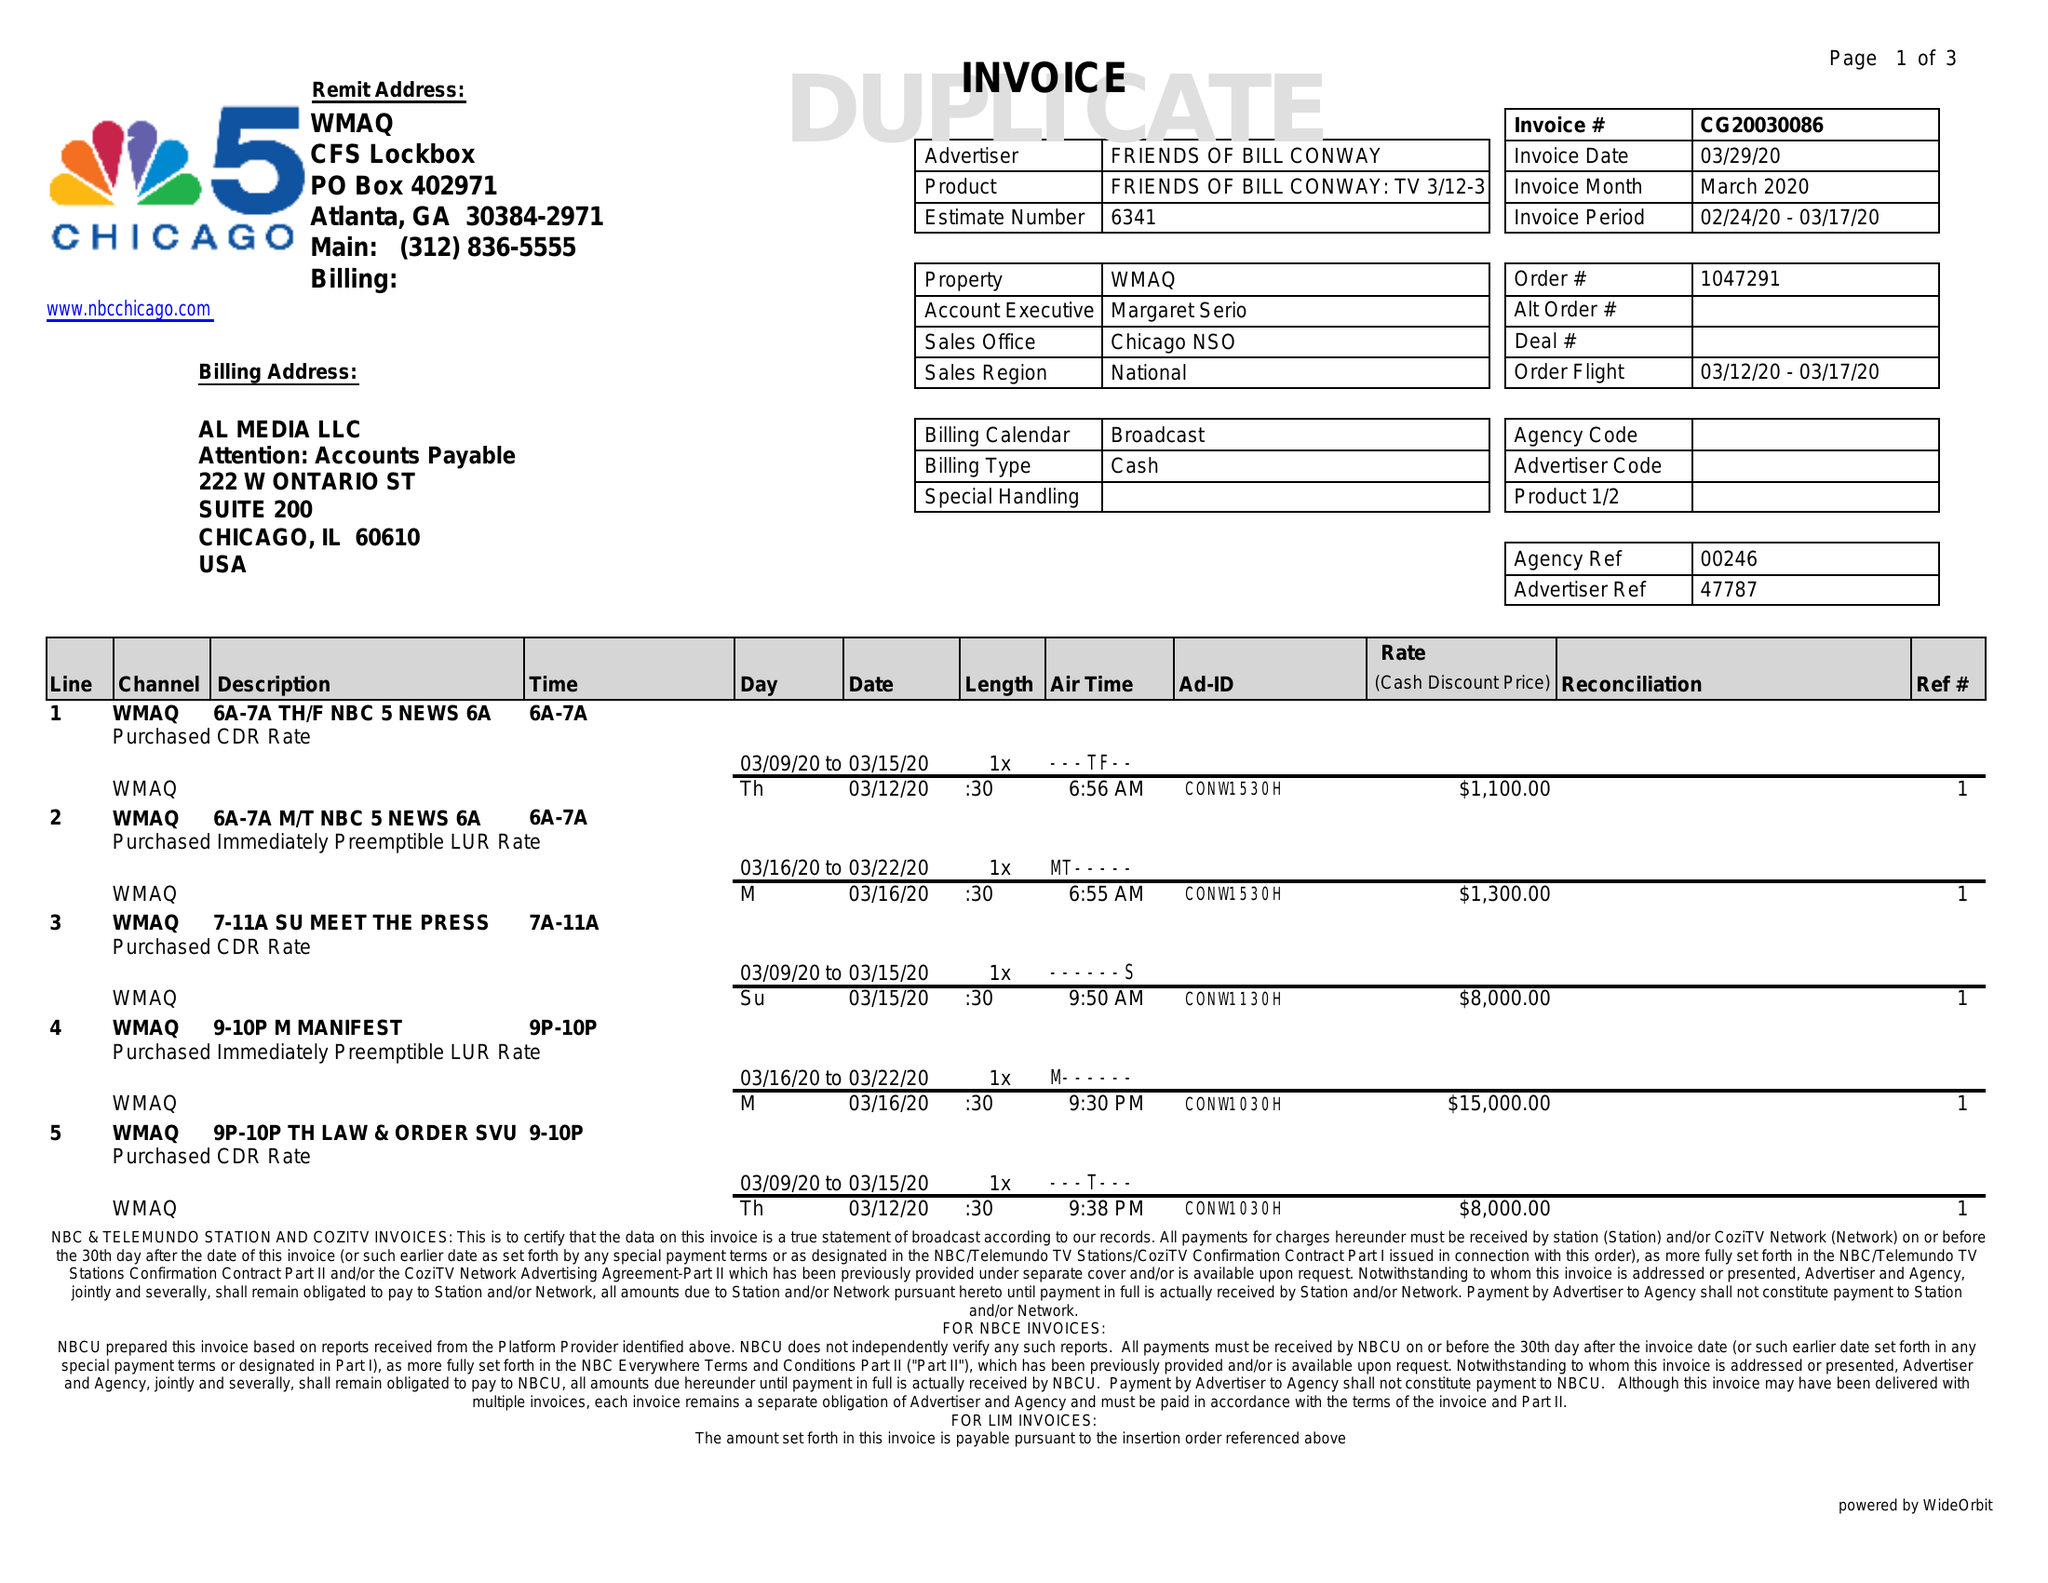What is the value for the contract_num?
Answer the question using a single word or phrase. CG20030086 